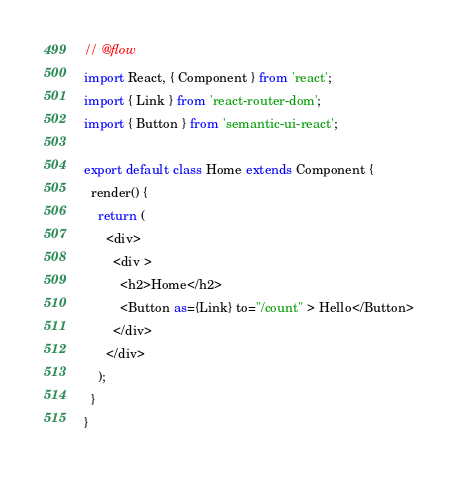Convert code to text. <code><loc_0><loc_0><loc_500><loc_500><_JavaScript_>// @flow
import React, { Component } from 'react';
import { Link } from 'react-router-dom';
import { Button } from 'semantic-ui-react';

export default class Home extends Component {
  render() {
    return (
      <div>
        <div >
          <h2>Home</h2>
          <Button as={Link} to="/count" > Hello</Button>
        </div>
      </div>
    );
  }
}
</code> 